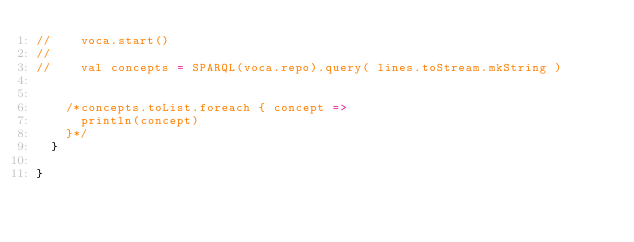Convert code to text. <code><loc_0><loc_0><loc_500><loc_500><_Scala_>//    voca.start()
//
//    val concepts = SPARQL(voca.repo).query( lines.toStream.mkString )


    /*concepts.toList.foreach { concept =>
      println(concept)
    }*/
  }

}
</code> 